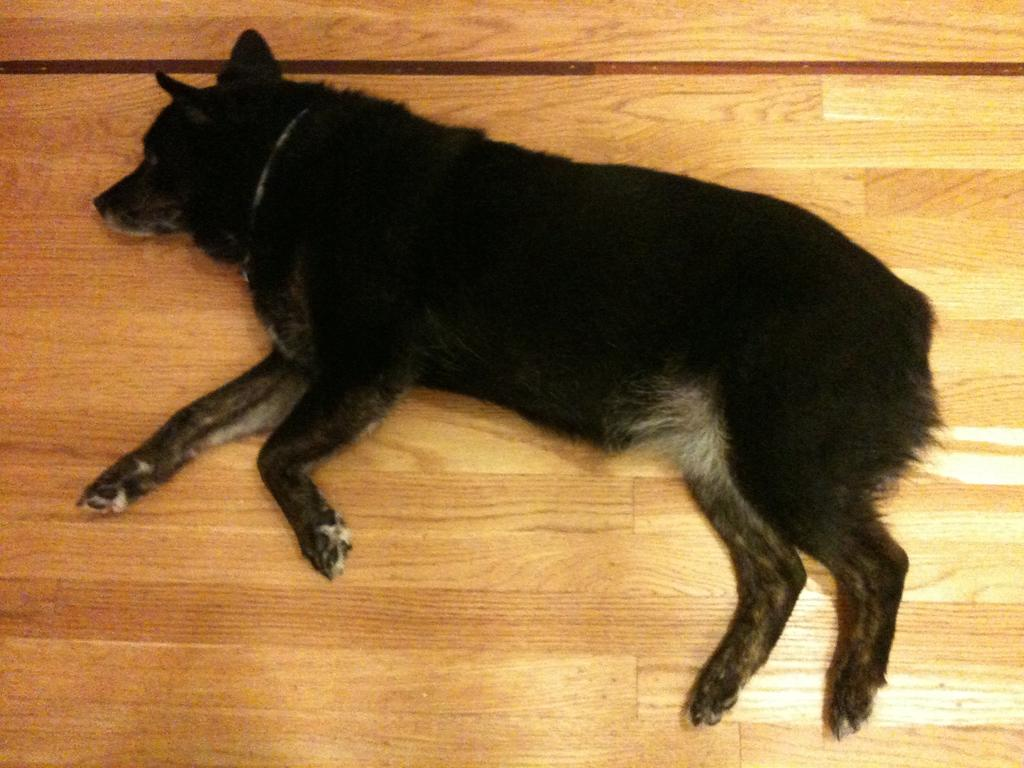What type of animal is present in the image? There is a dog in the image. Can you describe the surface the dog is lying on? The dog is lying on a wooden surface. Where is the doll hiding in the image? There is no doll present in the image. How many mice can be seen running around the dog in the image? There are no mice present in the image. 